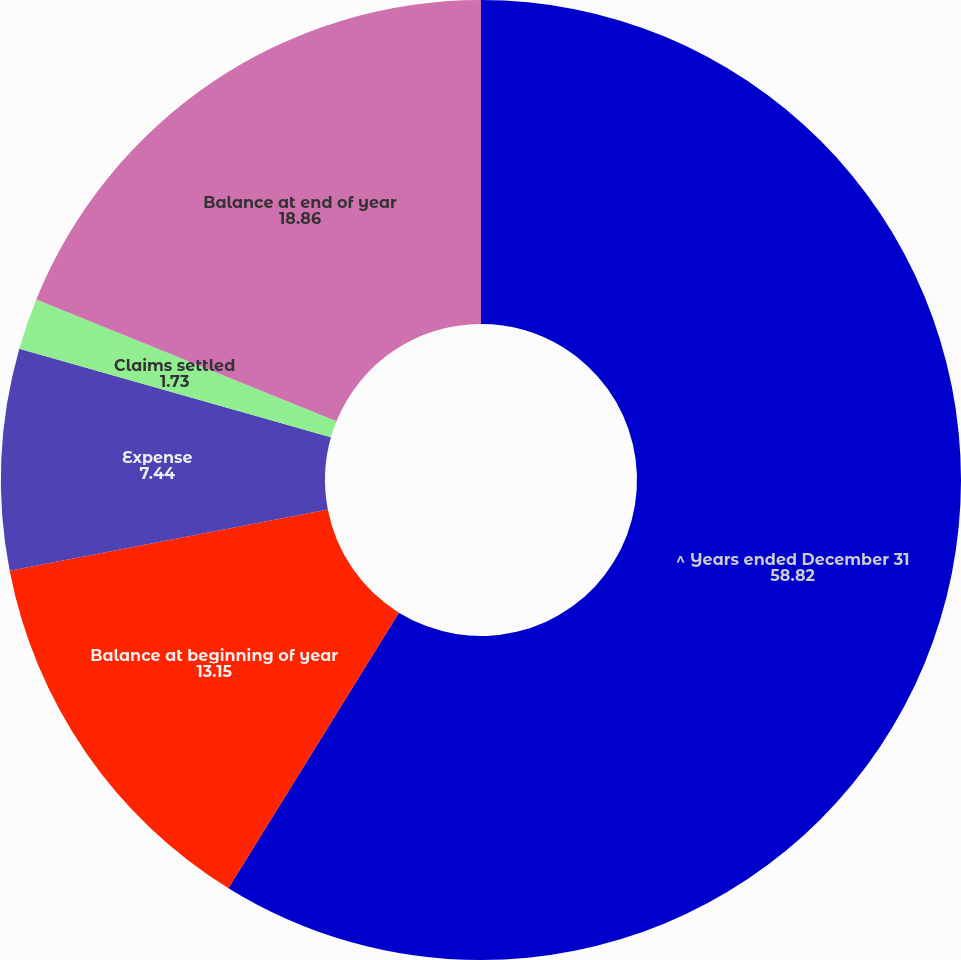Convert chart. <chart><loc_0><loc_0><loc_500><loc_500><pie_chart><fcel>^ Years ended December 31<fcel>Balance at beginning of year<fcel>Expense<fcel>Claims settled<fcel>Balance at end of year<nl><fcel>58.82%<fcel>13.15%<fcel>7.44%<fcel>1.73%<fcel>18.86%<nl></chart> 